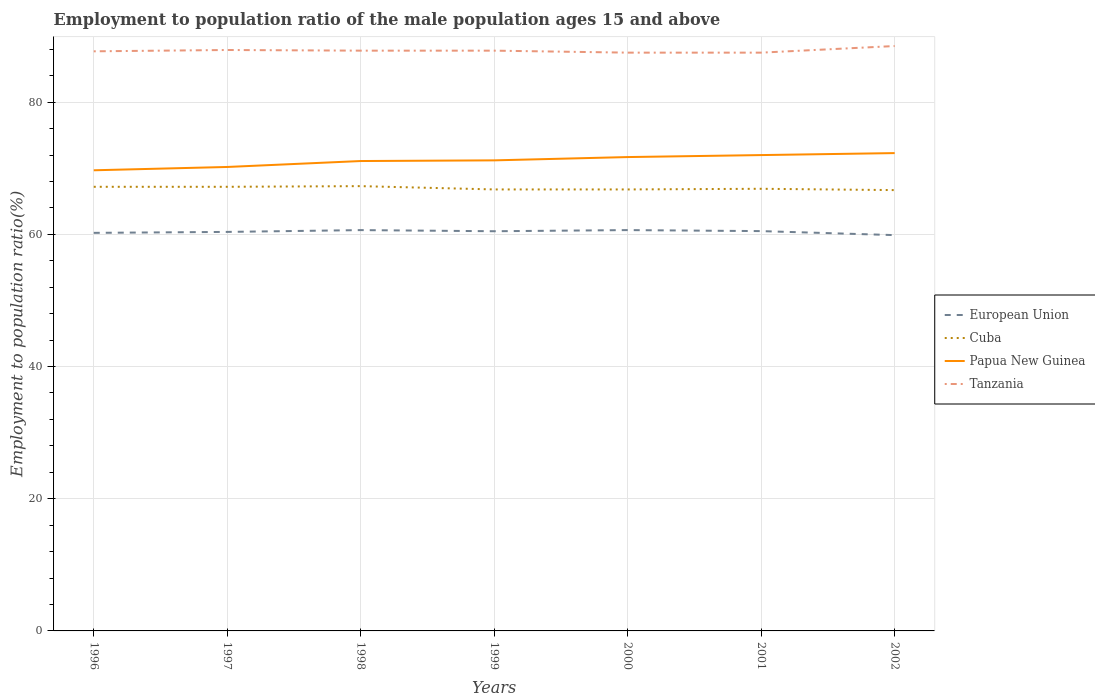How many different coloured lines are there?
Provide a short and direct response. 4. Does the line corresponding to European Union intersect with the line corresponding to Tanzania?
Make the answer very short. No. Is the number of lines equal to the number of legend labels?
Offer a very short reply. Yes. Across all years, what is the maximum employment to population ratio in Tanzania?
Provide a short and direct response. 87.5. In which year was the employment to population ratio in Papua New Guinea maximum?
Ensure brevity in your answer.  1996. What is the total employment to population ratio in European Union in the graph?
Keep it short and to the point. 0.49. What is the difference between the highest and the second highest employment to population ratio in Cuba?
Your answer should be very brief. 0.6. What is the difference between the highest and the lowest employment to population ratio in Tanzania?
Offer a terse response. 2. How many years are there in the graph?
Provide a short and direct response. 7. Are the values on the major ticks of Y-axis written in scientific E-notation?
Your answer should be very brief. No. Does the graph contain grids?
Offer a very short reply. Yes. Where does the legend appear in the graph?
Offer a very short reply. Center right. How many legend labels are there?
Provide a short and direct response. 4. What is the title of the graph?
Provide a short and direct response. Employment to population ratio of the male population ages 15 and above. Does "Togo" appear as one of the legend labels in the graph?
Give a very brief answer. No. What is the Employment to population ratio(%) of European Union in 1996?
Your answer should be compact. 60.23. What is the Employment to population ratio(%) in Cuba in 1996?
Ensure brevity in your answer.  67.2. What is the Employment to population ratio(%) in Papua New Guinea in 1996?
Offer a very short reply. 69.7. What is the Employment to population ratio(%) in Tanzania in 1996?
Offer a very short reply. 87.7. What is the Employment to population ratio(%) of European Union in 1997?
Provide a succinct answer. 60.37. What is the Employment to population ratio(%) of Cuba in 1997?
Ensure brevity in your answer.  67.2. What is the Employment to population ratio(%) in Papua New Guinea in 1997?
Your answer should be very brief. 70.2. What is the Employment to population ratio(%) of Tanzania in 1997?
Provide a short and direct response. 87.9. What is the Employment to population ratio(%) in European Union in 1998?
Your answer should be compact. 60.65. What is the Employment to population ratio(%) in Cuba in 1998?
Offer a terse response. 67.3. What is the Employment to population ratio(%) in Papua New Guinea in 1998?
Keep it short and to the point. 71.1. What is the Employment to population ratio(%) of Tanzania in 1998?
Make the answer very short. 87.8. What is the Employment to population ratio(%) of European Union in 1999?
Offer a terse response. 60.48. What is the Employment to population ratio(%) in Cuba in 1999?
Your answer should be compact. 66.8. What is the Employment to population ratio(%) in Papua New Guinea in 1999?
Give a very brief answer. 71.2. What is the Employment to population ratio(%) in Tanzania in 1999?
Give a very brief answer. 87.8. What is the Employment to population ratio(%) in European Union in 2000?
Keep it short and to the point. 60.65. What is the Employment to population ratio(%) in Cuba in 2000?
Ensure brevity in your answer.  66.8. What is the Employment to population ratio(%) in Papua New Guinea in 2000?
Your response must be concise. 71.7. What is the Employment to population ratio(%) of Tanzania in 2000?
Give a very brief answer. 87.5. What is the Employment to population ratio(%) of European Union in 2001?
Your answer should be very brief. 60.5. What is the Employment to population ratio(%) of Cuba in 2001?
Offer a very short reply. 66.9. What is the Employment to population ratio(%) of Tanzania in 2001?
Offer a terse response. 87.5. What is the Employment to population ratio(%) in European Union in 2002?
Your response must be concise. 59.89. What is the Employment to population ratio(%) of Cuba in 2002?
Keep it short and to the point. 66.7. What is the Employment to population ratio(%) in Papua New Guinea in 2002?
Keep it short and to the point. 72.3. What is the Employment to population ratio(%) of Tanzania in 2002?
Provide a short and direct response. 88.5. Across all years, what is the maximum Employment to population ratio(%) of European Union?
Your answer should be very brief. 60.65. Across all years, what is the maximum Employment to population ratio(%) of Cuba?
Offer a terse response. 67.3. Across all years, what is the maximum Employment to population ratio(%) of Papua New Guinea?
Offer a very short reply. 72.3. Across all years, what is the maximum Employment to population ratio(%) in Tanzania?
Your answer should be very brief. 88.5. Across all years, what is the minimum Employment to population ratio(%) in European Union?
Provide a short and direct response. 59.89. Across all years, what is the minimum Employment to population ratio(%) in Cuba?
Make the answer very short. 66.7. Across all years, what is the minimum Employment to population ratio(%) of Papua New Guinea?
Keep it short and to the point. 69.7. Across all years, what is the minimum Employment to population ratio(%) in Tanzania?
Offer a terse response. 87.5. What is the total Employment to population ratio(%) in European Union in the graph?
Give a very brief answer. 422.76. What is the total Employment to population ratio(%) of Cuba in the graph?
Your answer should be very brief. 468.9. What is the total Employment to population ratio(%) of Papua New Guinea in the graph?
Provide a short and direct response. 498.2. What is the total Employment to population ratio(%) in Tanzania in the graph?
Provide a succinct answer. 614.7. What is the difference between the Employment to population ratio(%) of European Union in 1996 and that in 1997?
Your answer should be compact. -0.14. What is the difference between the Employment to population ratio(%) in Papua New Guinea in 1996 and that in 1997?
Provide a short and direct response. -0.5. What is the difference between the Employment to population ratio(%) in Tanzania in 1996 and that in 1997?
Your response must be concise. -0.2. What is the difference between the Employment to population ratio(%) of European Union in 1996 and that in 1998?
Provide a succinct answer. -0.42. What is the difference between the Employment to population ratio(%) of Cuba in 1996 and that in 1998?
Offer a terse response. -0.1. What is the difference between the Employment to population ratio(%) in European Union in 1996 and that in 1999?
Offer a very short reply. -0.25. What is the difference between the Employment to population ratio(%) in Tanzania in 1996 and that in 1999?
Keep it short and to the point. -0.1. What is the difference between the Employment to population ratio(%) of European Union in 1996 and that in 2000?
Provide a short and direct response. -0.42. What is the difference between the Employment to population ratio(%) in Tanzania in 1996 and that in 2000?
Provide a short and direct response. 0.2. What is the difference between the Employment to population ratio(%) in European Union in 1996 and that in 2001?
Your answer should be compact. -0.26. What is the difference between the Employment to population ratio(%) in Papua New Guinea in 1996 and that in 2001?
Keep it short and to the point. -2.3. What is the difference between the Employment to population ratio(%) in European Union in 1996 and that in 2002?
Provide a short and direct response. 0.34. What is the difference between the Employment to population ratio(%) of Papua New Guinea in 1996 and that in 2002?
Provide a short and direct response. -2.6. What is the difference between the Employment to population ratio(%) of European Union in 1997 and that in 1998?
Your answer should be compact. -0.27. What is the difference between the Employment to population ratio(%) of Cuba in 1997 and that in 1998?
Your answer should be very brief. -0.1. What is the difference between the Employment to population ratio(%) in Papua New Guinea in 1997 and that in 1998?
Provide a succinct answer. -0.9. What is the difference between the Employment to population ratio(%) of European Union in 1997 and that in 1999?
Make the answer very short. -0.1. What is the difference between the Employment to population ratio(%) in Papua New Guinea in 1997 and that in 1999?
Offer a very short reply. -1. What is the difference between the Employment to population ratio(%) in Tanzania in 1997 and that in 1999?
Provide a short and direct response. 0.1. What is the difference between the Employment to population ratio(%) in European Union in 1997 and that in 2000?
Give a very brief answer. -0.27. What is the difference between the Employment to population ratio(%) in Cuba in 1997 and that in 2000?
Provide a short and direct response. 0.4. What is the difference between the Employment to population ratio(%) of Tanzania in 1997 and that in 2000?
Your response must be concise. 0.4. What is the difference between the Employment to population ratio(%) of European Union in 1997 and that in 2001?
Your answer should be very brief. -0.12. What is the difference between the Employment to population ratio(%) in Cuba in 1997 and that in 2001?
Your answer should be very brief. 0.3. What is the difference between the Employment to population ratio(%) of Papua New Guinea in 1997 and that in 2001?
Give a very brief answer. -1.8. What is the difference between the Employment to population ratio(%) in European Union in 1997 and that in 2002?
Provide a short and direct response. 0.49. What is the difference between the Employment to population ratio(%) in Cuba in 1997 and that in 2002?
Offer a very short reply. 0.5. What is the difference between the Employment to population ratio(%) in European Union in 1998 and that in 1999?
Your response must be concise. 0.17. What is the difference between the Employment to population ratio(%) of Cuba in 1998 and that in 1999?
Your answer should be very brief. 0.5. What is the difference between the Employment to population ratio(%) in Papua New Guinea in 1998 and that in 1999?
Ensure brevity in your answer.  -0.1. What is the difference between the Employment to population ratio(%) of European Union in 1998 and that in 2000?
Your response must be concise. -0. What is the difference between the Employment to population ratio(%) in European Union in 1998 and that in 2001?
Provide a succinct answer. 0.15. What is the difference between the Employment to population ratio(%) in Papua New Guinea in 1998 and that in 2001?
Offer a terse response. -0.9. What is the difference between the Employment to population ratio(%) in Tanzania in 1998 and that in 2001?
Offer a very short reply. 0.3. What is the difference between the Employment to population ratio(%) of European Union in 1998 and that in 2002?
Your answer should be very brief. 0.76. What is the difference between the Employment to population ratio(%) of European Union in 1999 and that in 2000?
Your answer should be compact. -0.17. What is the difference between the Employment to population ratio(%) of European Union in 1999 and that in 2001?
Your response must be concise. -0.02. What is the difference between the Employment to population ratio(%) of Tanzania in 1999 and that in 2001?
Provide a short and direct response. 0.3. What is the difference between the Employment to population ratio(%) of European Union in 1999 and that in 2002?
Give a very brief answer. 0.59. What is the difference between the Employment to population ratio(%) in Papua New Guinea in 1999 and that in 2002?
Offer a very short reply. -1.1. What is the difference between the Employment to population ratio(%) in Tanzania in 1999 and that in 2002?
Keep it short and to the point. -0.7. What is the difference between the Employment to population ratio(%) of European Union in 2000 and that in 2001?
Offer a very short reply. 0.15. What is the difference between the Employment to population ratio(%) of Cuba in 2000 and that in 2001?
Your response must be concise. -0.1. What is the difference between the Employment to population ratio(%) in European Union in 2000 and that in 2002?
Give a very brief answer. 0.76. What is the difference between the Employment to population ratio(%) of Cuba in 2000 and that in 2002?
Your response must be concise. 0.1. What is the difference between the Employment to population ratio(%) of Papua New Guinea in 2000 and that in 2002?
Your answer should be very brief. -0.6. What is the difference between the Employment to population ratio(%) in European Union in 2001 and that in 2002?
Offer a very short reply. 0.61. What is the difference between the Employment to population ratio(%) of Papua New Guinea in 2001 and that in 2002?
Make the answer very short. -0.3. What is the difference between the Employment to population ratio(%) of Tanzania in 2001 and that in 2002?
Keep it short and to the point. -1. What is the difference between the Employment to population ratio(%) in European Union in 1996 and the Employment to population ratio(%) in Cuba in 1997?
Provide a short and direct response. -6.97. What is the difference between the Employment to population ratio(%) of European Union in 1996 and the Employment to population ratio(%) of Papua New Guinea in 1997?
Your answer should be very brief. -9.97. What is the difference between the Employment to population ratio(%) of European Union in 1996 and the Employment to population ratio(%) of Tanzania in 1997?
Provide a short and direct response. -27.67. What is the difference between the Employment to population ratio(%) of Cuba in 1996 and the Employment to population ratio(%) of Papua New Guinea in 1997?
Offer a very short reply. -3. What is the difference between the Employment to population ratio(%) in Cuba in 1996 and the Employment to population ratio(%) in Tanzania in 1997?
Make the answer very short. -20.7. What is the difference between the Employment to population ratio(%) of Papua New Guinea in 1996 and the Employment to population ratio(%) of Tanzania in 1997?
Your answer should be very brief. -18.2. What is the difference between the Employment to population ratio(%) of European Union in 1996 and the Employment to population ratio(%) of Cuba in 1998?
Offer a very short reply. -7.07. What is the difference between the Employment to population ratio(%) of European Union in 1996 and the Employment to population ratio(%) of Papua New Guinea in 1998?
Your response must be concise. -10.87. What is the difference between the Employment to population ratio(%) in European Union in 1996 and the Employment to population ratio(%) in Tanzania in 1998?
Provide a short and direct response. -27.57. What is the difference between the Employment to population ratio(%) in Cuba in 1996 and the Employment to population ratio(%) in Papua New Guinea in 1998?
Ensure brevity in your answer.  -3.9. What is the difference between the Employment to population ratio(%) of Cuba in 1996 and the Employment to population ratio(%) of Tanzania in 1998?
Give a very brief answer. -20.6. What is the difference between the Employment to population ratio(%) of Papua New Guinea in 1996 and the Employment to population ratio(%) of Tanzania in 1998?
Your answer should be very brief. -18.1. What is the difference between the Employment to population ratio(%) of European Union in 1996 and the Employment to population ratio(%) of Cuba in 1999?
Give a very brief answer. -6.57. What is the difference between the Employment to population ratio(%) of European Union in 1996 and the Employment to population ratio(%) of Papua New Guinea in 1999?
Provide a short and direct response. -10.97. What is the difference between the Employment to population ratio(%) of European Union in 1996 and the Employment to population ratio(%) of Tanzania in 1999?
Offer a very short reply. -27.57. What is the difference between the Employment to population ratio(%) of Cuba in 1996 and the Employment to population ratio(%) of Papua New Guinea in 1999?
Make the answer very short. -4. What is the difference between the Employment to population ratio(%) of Cuba in 1996 and the Employment to population ratio(%) of Tanzania in 1999?
Keep it short and to the point. -20.6. What is the difference between the Employment to population ratio(%) of Papua New Guinea in 1996 and the Employment to population ratio(%) of Tanzania in 1999?
Your answer should be compact. -18.1. What is the difference between the Employment to population ratio(%) in European Union in 1996 and the Employment to population ratio(%) in Cuba in 2000?
Your response must be concise. -6.57. What is the difference between the Employment to population ratio(%) of European Union in 1996 and the Employment to population ratio(%) of Papua New Guinea in 2000?
Your answer should be compact. -11.47. What is the difference between the Employment to population ratio(%) of European Union in 1996 and the Employment to population ratio(%) of Tanzania in 2000?
Your answer should be compact. -27.27. What is the difference between the Employment to population ratio(%) of Cuba in 1996 and the Employment to population ratio(%) of Papua New Guinea in 2000?
Ensure brevity in your answer.  -4.5. What is the difference between the Employment to population ratio(%) in Cuba in 1996 and the Employment to population ratio(%) in Tanzania in 2000?
Ensure brevity in your answer.  -20.3. What is the difference between the Employment to population ratio(%) in Papua New Guinea in 1996 and the Employment to population ratio(%) in Tanzania in 2000?
Make the answer very short. -17.8. What is the difference between the Employment to population ratio(%) of European Union in 1996 and the Employment to population ratio(%) of Cuba in 2001?
Give a very brief answer. -6.67. What is the difference between the Employment to population ratio(%) in European Union in 1996 and the Employment to population ratio(%) in Papua New Guinea in 2001?
Offer a very short reply. -11.77. What is the difference between the Employment to population ratio(%) in European Union in 1996 and the Employment to population ratio(%) in Tanzania in 2001?
Ensure brevity in your answer.  -27.27. What is the difference between the Employment to population ratio(%) in Cuba in 1996 and the Employment to population ratio(%) in Tanzania in 2001?
Provide a short and direct response. -20.3. What is the difference between the Employment to population ratio(%) of Papua New Guinea in 1996 and the Employment to population ratio(%) of Tanzania in 2001?
Your response must be concise. -17.8. What is the difference between the Employment to population ratio(%) of European Union in 1996 and the Employment to population ratio(%) of Cuba in 2002?
Provide a short and direct response. -6.47. What is the difference between the Employment to population ratio(%) of European Union in 1996 and the Employment to population ratio(%) of Papua New Guinea in 2002?
Your answer should be very brief. -12.07. What is the difference between the Employment to population ratio(%) in European Union in 1996 and the Employment to population ratio(%) in Tanzania in 2002?
Your answer should be compact. -28.27. What is the difference between the Employment to population ratio(%) of Cuba in 1996 and the Employment to population ratio(%) of Tanzania in 2002?
Offer a terse response. -21.3. What is the difference between the Employment to population ratio(%) in Papua New Guinea in 1996 and the Employment to population ratio(%) in Tanzania in 2002?
Provide a succinct answer. -18.8. What is the difference between the Employment to population ratio(%) of European Union in 1997 and the Employment to population ratio(%) of Cuba in 1998?
Offer a terse response. -6.93. What is the difference between the Employment to population ratio(%) of European Union in 1997 and the Employment to population ratio(%) of Papua New Guinea in 1998?
Give a very brief answer. -10.73. What is the difference between the Employment to population ratio(%) in European Union in 1997 and the Employment to population ratio(%) in Tanzania in 1998?
Provide a short and direct response. -27.43. What is the difference between the Employment to population ratio(%) in Cuba in 1997 and the Employment to population ratio(%) in Tanzania in 1998?
Give a very brief answer. -20.6. What is the difference between the Employment to population ratio(%) of Papua New Guinea in 1997 and the Employment to population ratio(%) of Tanzania in 1998?
Offer a very short reply. -17.6. What is the difference between the Employment to population ratio(%) in European Union in 1997 and the Employment to population ratio(%) in Cuba in 1999?
Offer a terse response. -6.43. What is the difference between the Employment to population ratio(%) in European Union in 1997 and the Employment to population ratio(%) in Papua New Guinea in 1999?
Provide a short and direct response. -10.83. What is the difference between the Employment to population ratio(%) of European Union in 1997 and the Employment to population ratio(%) of Tanzania in 1999?
Your answer should be very brief. -27.43. What is the difference between the Employment to population ratio(%) of Cuba in 1997 and the Employment to population ratio(%) of Tanzania in 1999?
Provide a succinct answer. -20.6. What is the difference between the Employment to population ratio(%) in Papua New Guinea in 1997 and the Employment to population ratio(%) in Tanzania in 1999?
Your response must be concise. -17.6. What is the difference between the Employment to population ratio(%) in European Union in 1997 and the Employment to population ratio(%) in Cuba in 2000?
Keep it short and to the point. -6.43. What is the difference between the Employment to population ratio(%) of European Union in 1997 and the Employment to population ratio(%) of Papua New Guinea in 2000?
Your response must be concise. -11.33. What is the difference between the Employment to population ratio(%) of European Union in 1997 and the Employment to population ratio(%) of Tanzania in 2000?
Ensure brevity in your answer.  -27.13. What is the difference between the Employment to population ratio(%) of Cuba in 1997 and the Employment to population ratio(%) of Tanzania in 2000?
Your response must be concise. -20.3. What is the difference between the Employment to population ratio(%) of Papua New Guinea in 1997 and the Employment to population ratio(%) of Tanzania in 2000?
Your answer should be very brief. -17.3. What is the difference between the Employment to population ratio(%) in European Union in 1997 and the Employment to population ratio(%) in Cuba in 2001?
Offer a very short reply. -6.53. What is the difference between the Employment to population ratio(%) of European Union in 1997 and the Employment to population ratio(%) of Papua New Guinea in 2001?
Make the answer very short. -11.63. What is the difference between the Employment to population ratio(%) in European Union in 1997 and the Employment to population ratio(%) in Tanzania in 2001?
Give a very brief answer. -27.13. What is the difference between the Employment to population ratio(%) in Cuba in 1997 and the Employment to population ratio(%) in Papua New Guinea in 2001?
Your answer should be compact. -4.8. What is the difference between the Employment to population ratio(%) of Cuba in 1997 and the Employment to population ratio(%) of Tanzania in 2001?
Provide a succinct answer. -20.3. What is the difference between the Employment to population ratio(%) of Papua New Guinea in 1997 and the Employment to population ratio(%) of Tanzania in 2001?
Ensure brevity in your answer.  -17.3. What is the difference between the Employment to population ratio(%) in European Union in 1997 and the Employment to population ratio(%) in Cuba in 2002?
Provide a short and direct response. -6.33. What is the difference between the Employment to population ratio(%) of European Union in 1997 and the Employment to population ratio(%) of Papua New Guinea in 2002?
Offer a very short reply. -11.93. What is the difference between the Employment to population ratio(%) in European Union in 1997 and the Employment to population ratio(%) in Tanzania in 2002?
Your response must be concise. -28.13. What is the difference between the Employment to population ratio(%) in Cuba in 1997 and the Employment to population ratio(%) in Papua New Guinea in 2002?
Your answer should be compact. -5.1. What is the difference between the Employment to population ratio(%) in Cuba in 1997 and the Employment to population ratio(%) in Tanzania in 2002?
Ensure brevity in your answer.  -21.3. What is the difference between the Employment to population ratio(%) in Papua New Guinea in 1997 and the Employment to population ratio(%) in Tanzania in 2002?
Keep it short and to the point. -18.3. What is the difference between the Employment to population ratio(%) of European Union in 1998 and the Employment to population ratio(%) of Cuba in 1999?
Your answer should be very brief. -6.15. What is the difference between the Employment to population ratio(%) of European Union in 1998 and the Employment to population ratio(%) of Papua New Guinea in 1999?
Your answer should be very brief. -10.55. What is the difference between the Employment to population ratio(%) in European Union in 1998 and the Employment to population ratio(%) in Tanzania in 1999?
Your answer should be very brief. -27.15. What is the difference between the Employment to population ratio(%) of Cuba in 1998 and the Employment to population ratio(%) of Tanzania in 1999?
Offer a terse response. -20.5. What is the difference between the Employment to population ratio(%) in Papua New Guinea in 1998 and the Employment to population ratio(%) in Tanzania in 1999?
Give a very brief answer. -16.7. What is the difference between the Employment to population ratio(%) of European Union in 1998 and the Employment to population ratio(%) of Cuba in 2000?
Offer a terse response. -6.15. What is the difference between the Employment to population ratio(%) in European Union in 1998 and the Employment to population ratio(%) in Papua New Guinea in 2000?
Offer a very short reply. -11.05. What is the difference between the Employment to population ratio(%) of European Union in 1998 and the Employment to population ratio(%) of Tanzania in 2000?
Provide a succinct answer. -26.85. What is the difference between the Employment to population ratio(%) of Cuba in 1998 and the Employment to population ratio(%) of Papua New Guinea in 2000?
Your answer should be compact. -4.4. What is the difference between the Employment to population ratio(%) of Cuba in 1998 and the Employment to population ratio(%) of Tanzania in 2000?
Ensure brevity in your answer.  -20.2. What is the difference between the Employment to population ratio(%) in Papua New Guinea in 1998 and the Employment to population ratio(%) in Tanzania in 2000?
Offer a very short reply. -16.4. What is the difference between the Employment to population ratio(%) in European Union in 1998 and the Employment to population ratio(%) in Cuba in 2001?
Your answer should be compact. -6.25. What is the difference between the Employment to population ratio(%) of European Union in 1998 and the Employment to population ratio(%) of Papua New Guinea in 2001?
Your answer should be compact. -11.35. What is the difference between the Employment to population ratio(%) in European Union in 1998 and the Employment to population ratio(%) in Tanzania in 2001?
Give a very brief answer. -26.85. What is the difference between the Employment to population ratio(%) of Cuba in 1998 and the Employment to population ratio(%) of Tanzania in 2001?
Keep it short and to the point. -20.2. What is the difference between the Employment to population ratio(%) of Papua New Guinea in 1998 and the Employment to population ratio(%) of Tanzania in 2001?
Ensure brevity in your answer.  -16.4. What is the difference between the Employment to population ratio(%) in European Union in 1998 and the Employment to population ratio(%) in Cuba in 2002?
Offer a very short reply. -6.05. What is the difference between the Employment to population ratio(%) in European Union in 1998 and the Employment to population ratio(%) in Papua New Guinea in 2002?
Your answer should be very brief. -11.65. What is the difference between the Employment to population ratio(%) of European Union in 1998 and the Employment to population ratio(%) of Tanzania in 2002?
Offer a terse response. -27.85. What is the difference between the Employment to population ratio(%) of Cuba in 1998 and the Employment to population ratio(%) of Tanzania in 2002?
Provide a short and direct response. -21.2. What is the difference between the Employment to population ratio(%) of Papua New Guinea in 1998 and the Employment to population ratio(%) of Tanzania in 2002?
Ensure brevity in your answer.  -17.4. What is the difference between the Employment to population ratio(%) of European Union in 1999 and the Employment to population ratio(%) of Cuba in 2000?
Your response must be concise. -6.32. What is the difference between the Employment to population ratio(%) of European Union in 1999 and the Employment to population ratio(%) of Papua New Guinea in 2000?
Your answer should be very brief. -11.22. What is the difference between the Employment to population ratio(%) of European Union in 1999 and the Employment to population ratio(%) of Tanzania in 2000?
Your answer should be very brief. -27.02. What is the difference between the Employment to population ratio(%) of Cuba in 1999 and the Employment to population ratio(%) of Tanzania in 2000?
Make the answer very short. -20.7. What is the difference between the Employment to population ratio(%) of Papua New Guinea in 1999 and the Employment to population ratio(%) of Tanzania in 2000?
Give a very brief answer. -16.3. What is the difference between the Employment to population ratio(%) in European Union in 1999 and the Employment to population ratio(%) in Cuba in 2001?
Provide a succinct answer. -6.42. What is the difference between the Employment to population ratio(%) of European Union in 1999 and the Employment to population ratio(%) of Papua New Guinea in 2001?
Make the answer very short. -11.52. What is the difference between the Employment to population ratio(%) in European Union in 1999 and the Employment to population ratio(%) in Tanzania in 2001?
Your response must be concise. -27.02. What is the difference between the Employment to population ratio(%) in Cuba in 1999 and the Employment to population ratio(%) in Papua New Guinea in 2001?
Your answer should be very brief. -5.2. What is the difference between the Employment to population ratio(%) in Cuba in 1999 and the Employment to population ratio(%) in Tanzania in 2001?
Offer a terse response. -20.7. What is the difference between the Employment to population ratio(%) of Papua New Guinea in 1999 and the Employment to population ratio(%) of Tanzania in 2001?
Provide a short and direct response. -16.3. What is the difference between the Employment to population ratio(%) of European Union in 1999 and the Employment to population ratio(%) of Cuba in 2002?
Offer a very short reply. -6.22. What is the difference between the Employment to population ratio(%) of European Union in 1999 and the Employment to population ratio(%) of Papua New Guinea in 2002?
Keep it short and to the point. -11.82. What is the difference between the Employment to population ratio(%) of European Union in 1999 and the Employment to population ratio(%) of Tanzania in 2002?
Your answer should be compact. -28.02. What is the difference between the Employment to population ratio(%) of Cuba in 1999 and the Employment to population ratio(%) of Papua New Guinea in 2002?
Keep it short and to the point. -5.5. What is the difference between the Employment to population ratio(%) in Cuba in 1999 and the Employment to population ratio(%) in Tanzania in 2002?
Offer a terse response. -21.7. What is the difference between the Employment to population ratio(%) in Papua New Guinea in 1999 and the Employment to population ratio(%) in Tanzania in 2002?
Provide a succinct answer. -17.3. What is the difference between the Employment to population ratio(%) in European Union in 2000 and the Employment to population ratio(%) in Cuba in 2001?
Make the answer very short. -6.25. What is the difference between the Employment to population ratio(%) of European Union in 2000 and the Employment to population ratio(%) of Papua New Guinea in 2001?
Offer a terse response. -11.35. What is the difference between the Employment to population ratio(%) of European Union in 2000 and the Employment to population ratio(%) of Tanzania in 2001?
Your answer should be compact. -26.85. What is the difference between the Employment to population ratio(%) in Cuba in 2000 and the Employment to population ratio(%) in Tanzania in 2001?
Make the answer very short. -20.7. What is the difference between the Employment to population ratio(%) of Papua New Guinea in 2000 and the Employment to population ratio(%) of Tanzania in 2001?
Give a very brief answer. -15.8. What is the difference between the Employment to population ratio(%) in European Union in 2000 and the Employment to population ratio(%) in Cuba in 2002?
Give a very brief answer. -6.05. What is the difference between the Employment to population ratio(%) in European Union in 2000 and the Employment to population ratio(%) in Papua New Guinea in 2002?
Provide a succinct answer. -11.65. What is the difference between the Employment to population ratio(%) in European Union in 2000 and the Employment to population ratio(%) in Tanzania in 2002?
Ensure brevity in your answer.  -27.85. What is the difference between the Employment to population ratio(%) in Cuba in 2000 and the Employment to population ratio(%) in Papua New Guinea in 2002?
Provide a short and direct response. -5.5. What is the difference between the Employment to population ratio(%) of Cuba in 2000 and the Employment to population ratio(%) of Tanzania in 2002?
Make the answer very short. -21.7. What is the difference between the Employment to population ratio(%) in Papua New Guinea in 2000 and the Employment to population ratio(%) in Tanzania in 2002?
Your response must be concise. -16.8. What is the difference between the Employment to population ratio(%) of European Union in 2001 and the Employment to population ratio(%) of Cuba in 2002?
Offer a terse response. -6.2. What is the difference between the Employment to population ratio(%) of European Union in 2001 and the Employment to population ratio(%) of Papua New Guinea in 2002?
Ensure brevity in your answer.  -11.8. What is the difference between the Employment to population ratio(%) of European Union in 2001 and the Employment to population ratio(%) of Tanzania in 2002?
Your answer should be very brief. -28. What is the difference between the Employment to population ratio(%) in Cuba in 2001 and the Employment to population ratio(%) in Tanzania in 2002?
Your answer should be very brief. -21.6. What is the difference between the Employment to population ratio(%) in Papua New Guinea in 2001 and the Employment to population ratio(%) in Tanzania in 2002?
Offer a very short reply. -16.5. What is the average Employment to population ratio(%) in European Union per year?
Offer a very short reply. 60.39. What is the average Employment to population ratio(%) in Cuba per year?
Make the answer very short. 66.99. What is the average Employment to population ratio(%) of Papua New Guinea per year?
Your answer should be very brief. 71.17. What is the average Employment to population ratio(%) in Tanzania per year?
Keep it short and to the point. 87.81. In the year 1996, what is the difference between the Employment to population ratio(%) of European Union and Employment to population ratio(%) of Cuba?
Offer a very short reply. -6.97. In the year 1996, what is the difference between the Employment to population ratio(%) of European Union and Employment to population ratio(%) of Papua New Guinea?
Your answer should be compact. -9.47. In the year 1996, what is the difference between the Employment to population ratio(%) in European Union and Employment to population ratio(%) in Tanzania?
Ensure brevity in your answer.  -27.47. In the year 1996, what is the difference between the Employment to population ratio(%) in Cuba and Employment to population ratio(%) in Tanzania?
Keep it short and to the point. -20.5. In the year 1996, what is the difference between the Employment to population ratio(%) of Papua New Guinea and Employment to population ratio(%) of Tanzania?
Provide a short and direct response. -18. In the year 1997, what is the difference between the Employment to population ratio(%) of European Union and Employment to population ratio(%) of Cuba?
Offer a terse response. -6.83. In the year 1997, what is the difference between the Employment to population ratio(%) in European Union and Employment to population ratio(%) in Papua New Guinea?
Make the answer very short. -9.83. In the year 1997, what is the difference between the Employment to population ratio(%) in European Union and Employment to population ratio(%) in Tanzania?
Offer a very short reply. -27.53. In the year 1997, what is the difference between the Employment to population ratio(%) of Cuba and Employment to population ratio(%) of Tanzania?
Make the answer very short. -20.7. In the year 1997, what is the difference between the Employment to population ratio(%) of Papua New Guinea and Employment to population ratio(%) of Tanzania?
Give a very brief answer. -17.7. In the year 1998, what is the difference between the Employment to population ratio(%) in European Union and Employment to population ratio(%) in Cuba?
Make the answer very short. -6.65. In the year 1998, what is the difference between the Employment to population ratio(%) of European Union and Employment to population ratio(%) of Papua New Guinea?
Your answer should be very brief. -10.45. In the year 1998, what is the difference between the Employment to population ratio(%) in European Union and Employment to population ratio(%) in Tanzania?
Ensure brevity in your answer.  -27.15. In the year 1998, what is the difference between the Employment to population ratio(%) of Cuba and Employment to population ratio(%) of Tanzania?
Keep it short and to the point. -20.5. In the year 1998, what is the difference between the Employment to population ratio(%) in Papua New Guinea and Employment to population ratio(%) in Tanzania?
Provide a succinct answer. -16.7. In the year 1999, what is the difference between the Employment to population ratio(%) in European Union and Employment to population ratio(%) in Cuba?
Provide a succinct answer. -6.32. In the year 1999, what is the difference between the Employment to population ratio(%) of European Union and Employment to population ratio(%) of Papua New Guinea?
Provide a short and direct response. -10.72. In the year 1999, what is the difference between the Employment to population ratio(%) in European Union and Employment to population ratio(%) in Tanzania?
Keep it short and to the point. -27.32. In the year 1999, what is the difference between the Employment to population ratio(%) in Cuba and Employment to population ratio(%) in Papua New Guinea?
Your answer should be compact. -4.4. In the year 1999, what is the difference between the Employment to population ratio(%) in Cuba and Employment to population ratio(%) in Tanzania?
Ensure brevity in your answer.  -21. In the year 1999, what is the difference between the Employment to population ratio(%) of Papua New Guinea and Employment to population ratio(%) of Tanzania?
Your answer should be very brief. -16.6. In the year 2000, what is the difference between the Employment to population ratio(%) of European Union and Employment to population ratio(%) of Cuba?
Your answer should be very brief. -6.15. In the year 2000, what is the difference between the Employment to population ratio(%) in European Union and Employment to population ratio(%) in Papua New Guinea?
Offer a terse response. -11.05. In the year 2000, what is the difference between the Employment to population ratio(%) of European Union and Employment to population ratio(%) of Tanzania?
Keep it short and to the point. -26.85. In the year 2000, what is the difference between the Employment to population ratio(%) in Cuba and Employment to population ratio(%) in Tanzania?
Your response must be concise. -20.7. In the year 2000, what is the difference between the Employment to population ratio(%) of Papua New Guinea and Employment to population ratio(%) of Tanzania?
Offer a very short reply. -15.8. In the year 2001, what is the difference between the Employment to population ratio(%) of European Union and Employment to population ratio(%) of Cuba?
Make the answer very short. -6.4. In the year 2001, what is the difference between the Employment to population ratio(%) of European Union and Employment to population ratio(%) of Papua New Guinea?
Provide a short and direct response. -11.5. In the year 2001, what is the difference between the Employment to population ratio(%) in European Union and Employment to population ratio(%) in Tanzania?
Offer a very short reply. -27. In the year 2001, what is the difference between the Employment to population ratio(%) in Cuba and Employment to population ratio(%) in Tanzania?
Your answer should be compact. -20.6. In the year 2001, what is the difference between the Employment to population ratio(%) in Papua New Guinea and Employment to population ratio(%) in Tanzania?
Make the answer very short. -15.5. In the year 2002, what is the difference between the Employment to population ratio(%) of European Union and Employment to population ratio(%) of Cuba?
Offer a terse response. -6.81. In the year 2002, what is the difference between the Employment to population ratio(%) in European Union and Employment to population ratio(%) in Papua New Guinea?
Offer a terse response. -12.41. In the year 2002, what is the difference between the Employment to population ratio(%) of European Union and Employment to population ratio(%) of Tanzania?
Keep it short and to the point. -28.61. In the year 2002, what is the difference between the Employment to population ratio(%) in Cuba and Employment to population ratio(%) in Tanzania?
Make the answer very short. -21.8. In the year 2002, what is the difference between the Employment to population ratio(%) in Papua New Guinea and Employment to population ratio(%) in Tanzania?
Provide a succinct answer. -16.2. What is the ratio of the Employment to population ratio(%) of Cuba in 1996 to that in 1997?
Provide a short and direct response. 1. What is the ratio of the Employment to population ratio(%) of Papua New Guinea in 1996 to that in 1997?
Ensure brevity in your answer.  0.99. What is the ratio of the Employment to population ratio(%) of Tanzania in 1996 to that in 1997?
Provide a short and direct response. 1. What is the ratio of the Employment to population ratio(%) of European Union in 1996 to that in 1998?
Offer a very short reply. 0.99. What is the ratio of the Employment to population ratio(%) in Cuba in 1996 to that in 1998?
Offer a terse response. 1. What is the ratio of the Employment to population ratio(%) of Papua New Guinea in 1996 to that in 1998?
Offer a very short reply. 0.98. What is the ratio of the Employment to population ratio(%) in Papua New Guinea in 1996 to that in 1999?
Provide a short and direct response. 0.98. What is the ratio of the Employment to population ratio(%) in Tanzania in 1996 to that in 1999?
Keep it short and to the point. 1. What is the ratio of the Employment to population ratio(%) of European Union in 1996 to that in 2000?
Make the answer very short. 0.99. What is the ratio of the Employment to population ratio(%) of Papua New Guinea in 1996 to that in 2000?
Offer a very short reply. 0.97. What is the ratio of the Employment to population ratio(%) in Tanzania in 1996 to that in 2000?
Your answer should be very brief. 1. What is the ratio of the Employment to population ratio(%) in European Union in 1996 to that in 2001?
Provide a short and direct response. 1. What is the ratio of the Employment to population ratio(%) in Papua New Guinea in 1996 to that in 2001?
Your answer should be very brief. 0.97. What is the ratio of the Employment to population ratio(%) in European Union in 1996 to that in 2002?
Your answer should be compact. 1.01. What is the ratio of the Employment to population ratio(%) of Cuba in 1996 to that in 2002?
Keep it short and to the point. 1.01. What is the ratio of the Employment to population ratio(%) of European Union in 1997 to that in 1998?
Give a very brief answer. 1. What is the ratio of the Employment to population ratio(%) of Papua New Guinea in 1997 to that in 1998?
Your answer should be very brief. 0.99. What is the ratio of the Employment to population ratio(%) of European Union in 1997 to that in 1999?
Make the answer very short. 1. What is the ratio of the Employment to population ratio(%) of Cuba in 1997 to that in 1999?
Offer a terse response. 1.01. What is the ratio of the Employment to population ratio(%) of Tanzania in 1997 to that in 1999?
Give a very brief answer. 1. What is the ratio of the Employment to population ratio(%) in European Union in 1997 to that in 2000?
Make the answer very short. 1. What is the ratio of the Employment to population ratio(%) in Cuba in 1997 to that in 2000?
Ensure brevity in your answer.  1.01. What is the ratio of the Employment to population ratio(%) of Papua New Guinea in 1997 to that in 2000?
Ensure brevity in your answer.  0.98. What is the ratio of the Employment to population ratio(%) of Tanzania in 1997 to that in 2000?
Offer a terse response. 1. What is the ratio of the Employment to population ratio(%) in European Union in 1997 to that in 2001?
Make the answer very short. 1. What is the ratio of the Employment to population ratio(%) in Cuba in 1997 to that in 2001?
Offer a very short reply. 1. What is the ratio of the Employment to population ratio(%) in Papua New Guinea in 1997 to that in 2001?
Your response must be concise. 0.97. What is the ratio of the Employment to population ratio(%) of Tanzania in 1997 to that in 2001?
Provide a short and direct response. 1. What is the ratio of the Employment to population ratio(%) in Cuba in 1997 to that in 2002?
Your response must be concise. 1.01. What is the ratio of the Employment to population ratio(%) in Papua New Guinea in 1997 to that in 2002?
Make the answer very short. 0.97. What is the ratio of the Employment to population ratio(%) of Cuba in 1998 to that in 1999?
Ensure brevity in your answer.  1.01. What is the ratio of the Employment to population ratio(%) of Tanzania in 1998 to that in 1999?
Make the answer very short. 1. What is the ratio of the Employment to population ratio(%) of Cuba in 1998 to that in 2000?
Your answer should be very brief. 1.01. What is the ratio of the Employment to population ratio(%) in Tanzania in 1998 to that in 2000?
Provide a short and direct response. 1. What is the ratio of the Employment to population ratio(%) in Papua New Guinea in 1998 to that in 2001?
Provide a succinct answer. 0.99. What is the ratio of the Employment to population ratio(%) in European Union in 1998 to that in 2002?
Make the answer very short. 1.01. What is the ratio of the Employment to population ratio(%) in Cuba in 1998 to that in 2002?
Your answer should be compact. 1.01. What is the ratio of the Employment to population ratio(%) in Papua New Guinea in 1998 to that in 2002?
Provide a short and direct response. 0.98. What is the ratio of the Employment to population ratio(%) of European Union in 1999 to that in 2000?
Keep it short and to the point. 1. What is the ratio of the Employment to population ratio(%) of Cuba in 1999 to that in 2000?
Keep it short and to the point. 1. What is the ratio of the Employment to population ratio(%) of Papua New Guinea in 1999 to that in 2000?
Give a very brief answer. 0.99. What is the ratio of the Employment to population ratio(%) in European Union in 1999 to that in 2001?
Your answer should be very brief. 1. What is the ratio of the Employment to population ratio(%) in Papua New Guinea in 1999 to that in 2001?
Give a very brief answer. 0.99. What is the ratio of the Employment to population ratio(%) in Tanzania in 1999 to that in 2001?
Keep it short and to the point. 1. What is the ratio of the Employment to population ratio(%) in European Union in 1999 to that in 2002?
Ensure brevity in your answer.  1.01. What is the ratio of the Employment to population ratio(%) in Cuba in 1999 to that in 2002?
Your answer should be very brief. 1. What is the ratio of the Employment to population ratio(%) in Papua New Guinea in 1999 to that in 2002?
Make the answer very short. 0.98. What is the ratio of the Employment to population ratio(%) of Tanzania in 2000 to that in 2001?
Ensure brevity in your answer.  1. What is the ratio of the Employment to population ratio(%) of European Union in 2000 to that in 2002?
Keep it short and to the point. 1.01. What is the ratio of the Employment to population ratio(%) of Cuba in 2000 to that in 2002?
Give a very brief answer. 1. What is the ratio of the Employment to population ratio(%) in Tanzania in 2000 to that in 2002?
Give a very brief answer. 0.99. What is the ratio of the Employment to population ratio(%) in Tanzania in 2001 to that in 2002?
Your answer should be compact. 0.99. What is the difference between the highest and the second highest Employment to population ratio(%) in European Union?
Give a very brief answer. 0. What is the difference between the highest and the second highest Employment to population ratio(%) of Papua New Guinea?
Provide a succinct answer. 0.3. What is the difference between the highest and the lowest Employment to population ratio(%) in European Union?
Offer a very short reply. 0.76. What is the difference between the highest and the lowest Employment to population ratio(%) in Tanzania?
Your answer should be very brief. 1. 